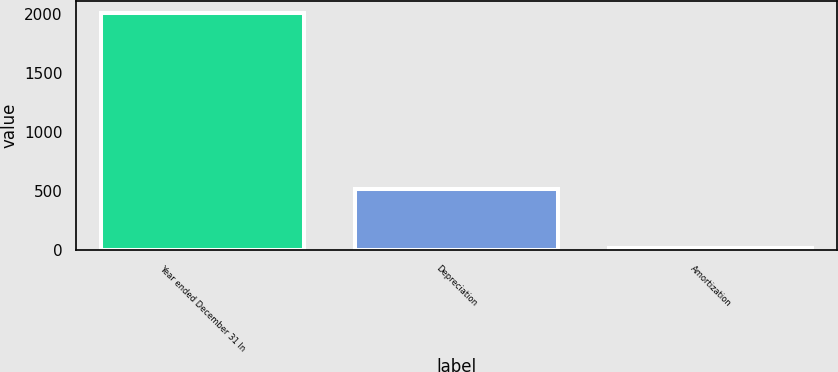<chart> <loc_0><loc_0><loc_500><loc_500><bar_chart><fcel>Year ended December 31 In<fcel>Depreciation<fcel>Amortization<nl><fcel>2012<fcel>521<fcel>19<nl></chart> 